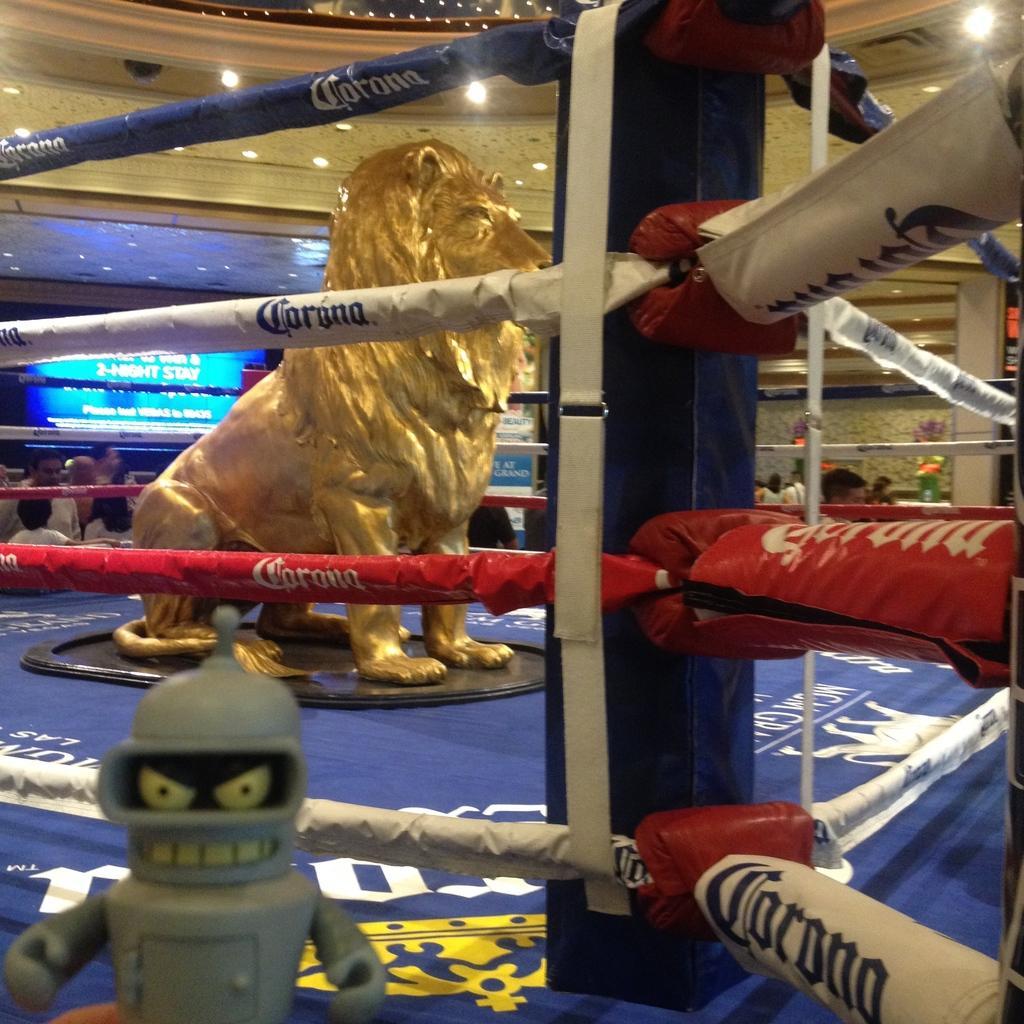Please provide a concise description of this image. In front of the image there is a toy. There is a depiction of a lion in the boxing ring. Behind the ring there are people. There is a screen. There are flower pots and boards with some text on it. At the top of the image there are lights. 